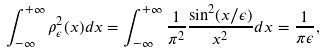<formula> <loc_0><loc_0><loc_500><loc_500>\int _ { - \infty } ^ { + \infty } \rho _ { \epsilon } ^ { 2 } ( x ) d x = \int _ { - \infty } ^ { + \infty } \frac { 1 } { \pi ^ { 2 } } \frac { \sin ^ { 2 } ( x / \epsilon ) } { x ^ { 2 } } d x = \frac { 1 } { \pi \epsilon } ,</formula> 